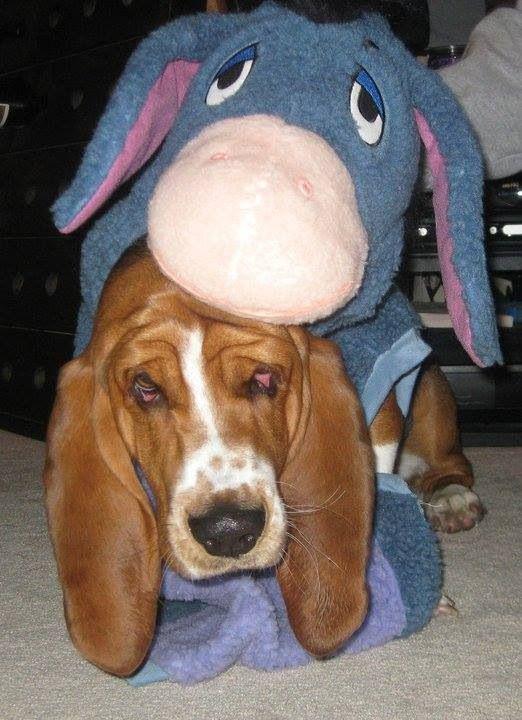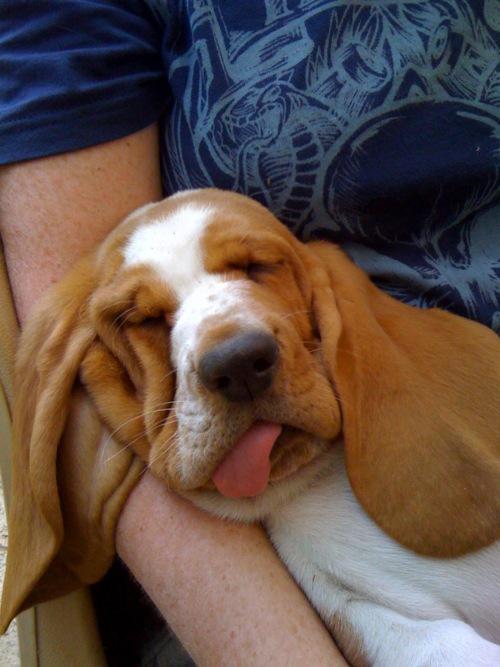The first image is the image on the left, the second image is the image on the right. Examine the images to the left and right. Is the description "a dog is wearing a costume" accurate? Answer yes or no. Yes. 